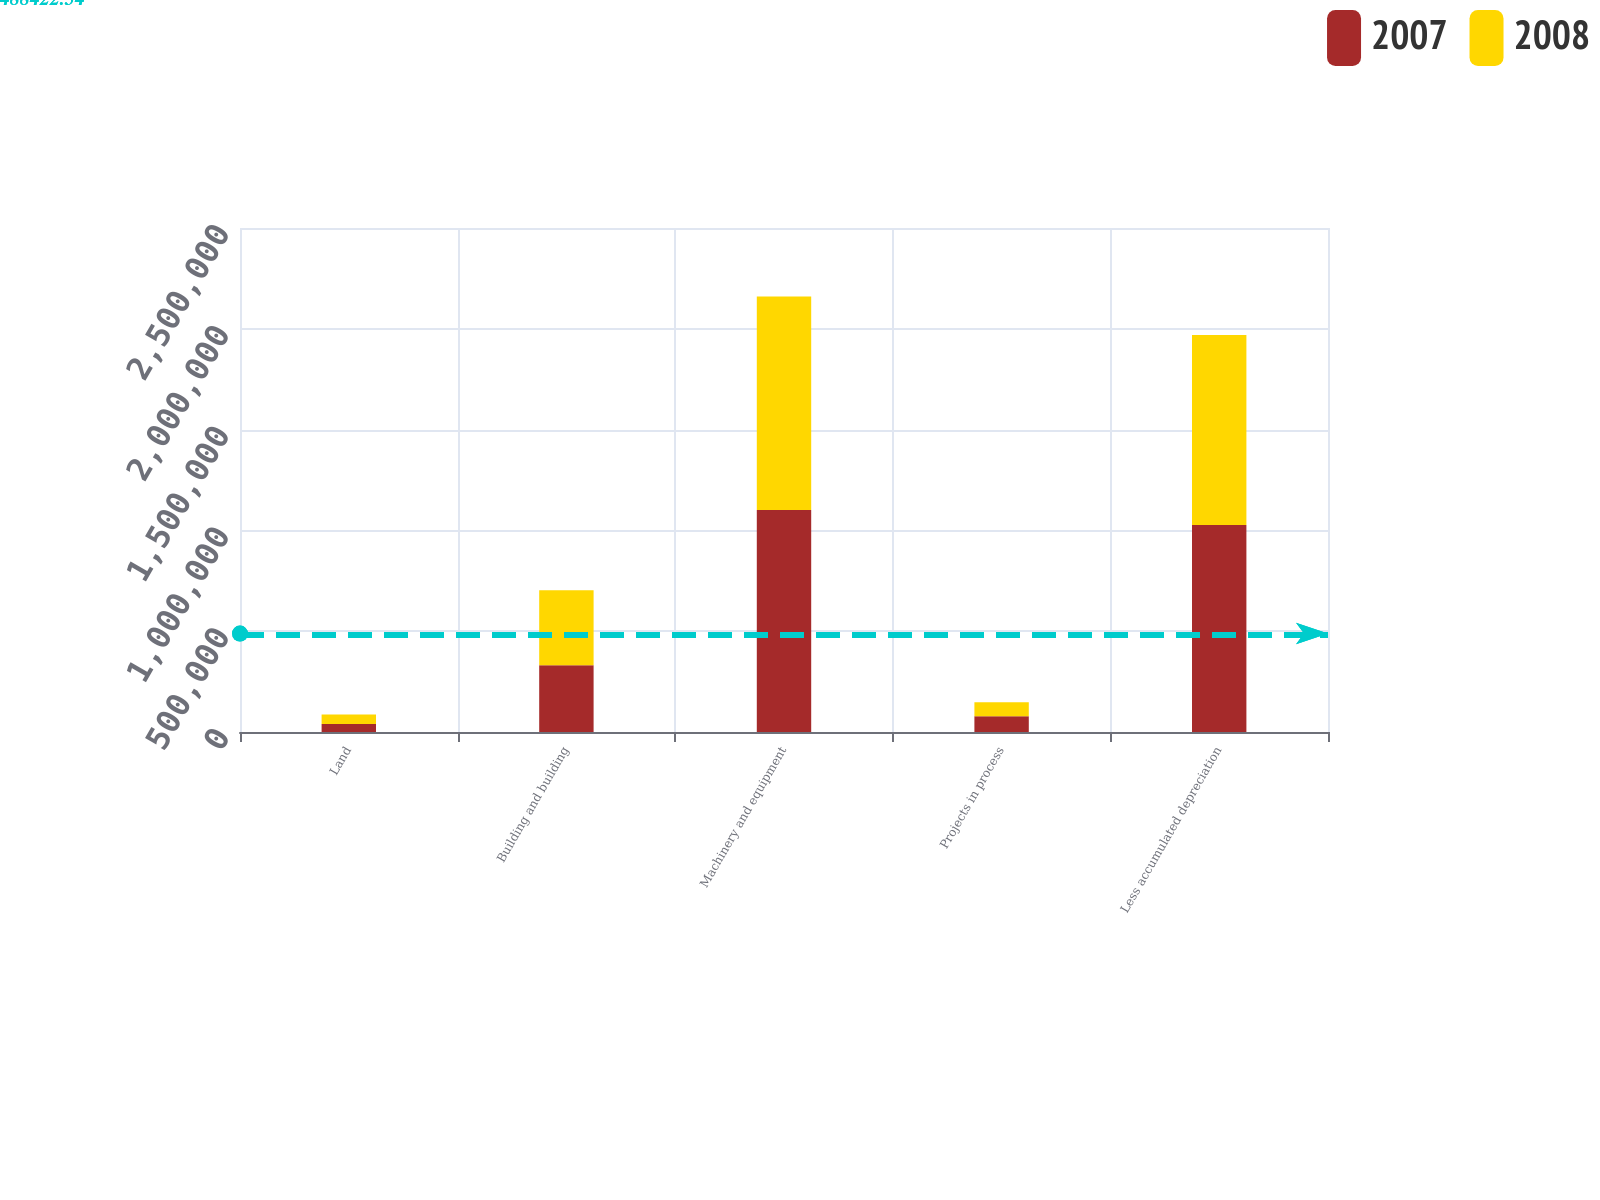<chart> <loc_0><loc_0><loc_500><loc_500><stacked_bar_chart><ecel><fcel>Land<fcel>Building and building<fcel>Machinery and equipment<fcel>Projects in process<fcel>Less accumulated depreciation<nl><fcel>2007<fcel>39764<fcel>330519<fcel>1.10076e+06<fcel>78073<fcel>1.02681e+06<nl><fcel>2008<fcel>47212<fcel>372149<fcel>1.05956e+06<fcel>69040<fcel>942244<nl></chart> 